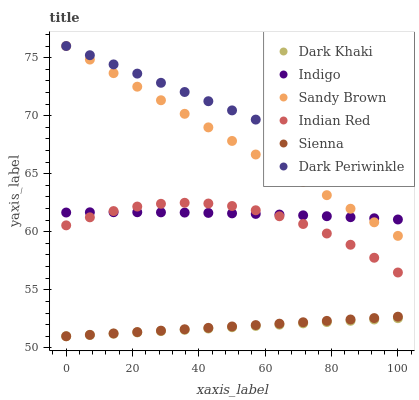Does Dark Khaki have the minimum area under the curve?
Answer yes or no. Yes. Does Dark Periwinkle have the maximum area under the curve?
Answer yes or no. Yes. Does Indigo have the minimum area under the curve?
Answer yes or no. No. Does Indigo have the maximum area under the curve?
Answer yes or no. No. Is Dark Khaki the smoothest?
Answer yes or no. Yes. Is Indian Red the roughest?
Answer yes or no. Yes. Is Indigo the smoothest?
Answer yes or no. No. Is Indigo the roughest?
Answer yes or no. No. Does Sienna have the lowest value?
Answer yes or no. Yes. Does Indigo have the lowest value?
Answer yes or no. No. Does Dark Periwinkle have the highest value?
Answer yes or no. Yes. Does Indigo have the highest value?
Answer yes or no. No. Is Dark Khaki less than Indigo?
Answer yes or no. Yes. Is Sandy Brown greater than Dark Khaki?
Answer yes or no. Yes. Does Sandy Brown intersect Dark Periwinkle?
Answer yes or no. Yes. Is Sandy Brown less than Dark Periwinkle?
Answer yes or no. No. Is Sandy Brown greater than Dark Periwinkle?
Answer yes or no. No. Does Dark Khaki intersect Indigo?
Answer yes or no. No. 